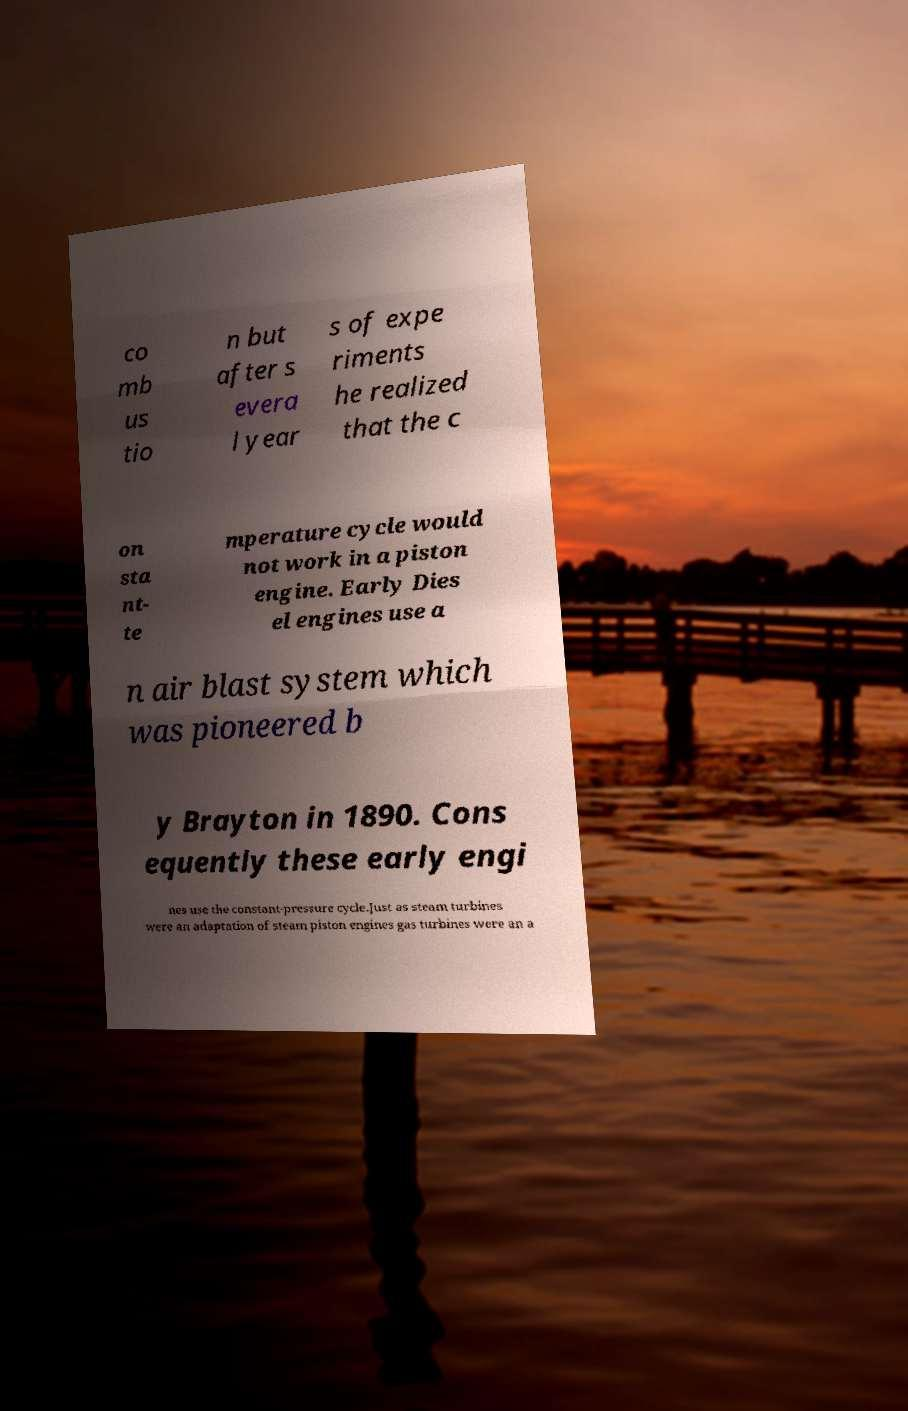Could you assist in decoding the text presented in this image and type it out clearly? co mb us tio n but after s evera l year s of expe riments he realized that the c on sta nt- te mperature cycle would not work in a piston engine. Early Dies el engines use a n air blast system which was pioneered b y Brayton in 1890. Cons equently these early engi nes use the constant-pressure cycle.Just as steam turbines were an adaptation of steam piston engines gas turbines were an a 